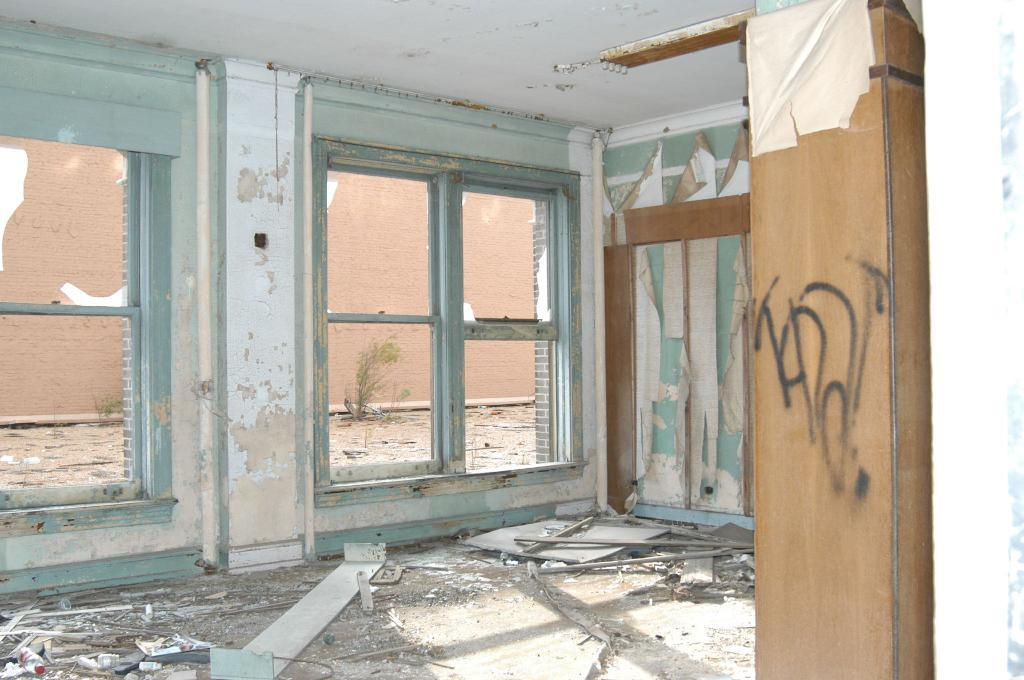What architectural features can be seen in the image? There are windows, a wall, and a wooden pillar visible in the image. What is on the ground in the image? There are objects on the ground in the image. What can be seen from the windows in the image? From the windows, a wall is visible. What type of approval is required for the chickens in the image? There are no chickens present in the image, so approval is not relevant to the image. How does the acoustics of the room affect the sound in the image? The provided facts do not mention anything about the acoustics of the room, so it is not possible to determine how it affects the sound in the image. 